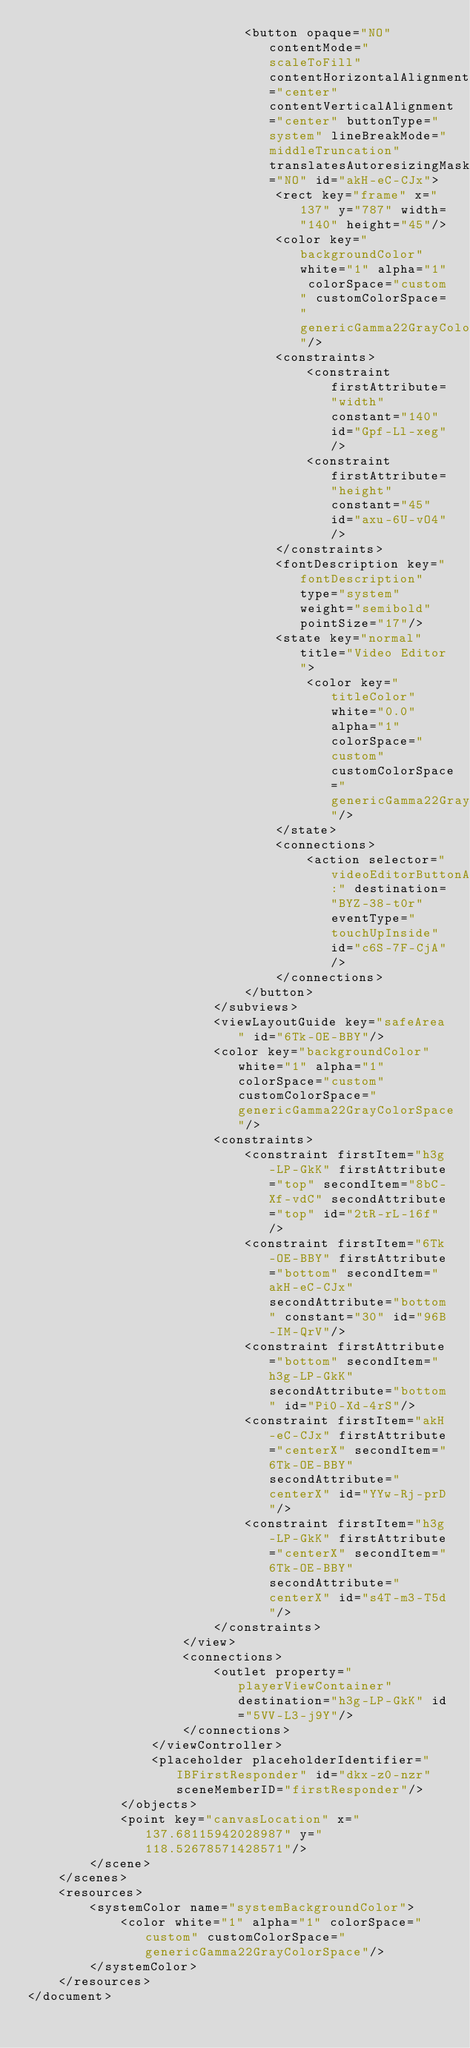<code> <loc_0><loc_0><loc_500><loc_500><_XML_>                            <button opaque="NO" contentMode="scaleToFill" contentHorizontalAlignment="center" contentVerticalAlignment="center" buttonType="system" lineBreakMode="middleTruncation" translatesAutoresizingMaskIntoConstraints="NO" id="akH-eC-CJx">
                                <rect key="frame" x="137" y="787" width="140" height="45"/>
                                <color key="backgroundColor" white="1" alpha="1" colorSpace="custom" customColorSpace="genericGamma22GrayColorSpace"/>
                                <constraints>
                                    <constraint firstAttribute="width" constant="140" id="Gpf-Ll-xeg"/>
                                    <constraint firstAttribute="height" constant="45" id="axu-6U-vO4"/>
                                </constraints>
                                <fontDescription key="fontDescription" type="system" weight="semibold" pointSize="17"/>
                                <state key="normal" title="Video Editor">
                                    <color key="titleColor" white="0.0" alpha="1" colorSpace="custom" customColorSpace="genericGamma22GrayColorSpace"/>
                                </state>
                                <connections>
                                    <action selector="videoEditorButtonAction:" destination="BYZ-38-t0r" eventType="touchUpInside" id="c6S-7F-CjA"/>
                                </connections>
                            </button>
                        </subviews>
                        <viewLayoutGuide key="safeArea" id="6Tk-OE-BBY"/>
                        <color key="backgroundColor" white="1" alpha="1" colorSpace="custom" customColorSpace="genericGamma22GrayColorSpace"/>
                        <constraints>
                            <constraint firstItem="h3g-LP-GkK" firstAttribute="top" secondItem="8bC-Xf-vdC" secondAttribute="top" id="2tR-rL-16f"/>
                            <constraint firstItem="6Tk-OE-BBY" firstAttribute="bottom" secondItem="akH-eC-CJx" secondAttribute="bottom" constant="30" id="96B-IM-QrV"/>
                            <constraint firstAttribute="bottom" secondItem="h3g-LP-GkK" secondAttribute="bottom" id="Pi0-Xd-4rS"/>
                            <constraint firstItem="akH-eC-CJx" firstAttribute="centerX" secondItem="6Tk-OE-BBY" secondAttribute="centerX" id="YYw-Rj-prD"/>
                            <constraint firstItem="h3g-LP-GkK" firstAttribute="centerX" secondItem="6Tk-OE-BBY" secondAttribute="centerX" id="s4T-m3-T5d"/>
                        </constraints>
                    </view>
                    <connections>
                        <outlet property="playerViewContainer" destination="h3g-LP-GkK" id="5VV-L3-j9Y"/>
                    </connections>
                </viewController>
                <placeholder placeholderIdentifier="IBFirstResponder" id="dkx-z0-nzr" sceneMemberID="firstResponder"/>
            </objects>
            <point key="canvasLocation" x="137.68115942028987" y="118.52678571428571"/>
        </scene>
    </scenes>
    <resources>
        <systemColor name="systemBackgroundColor">
            <color white="1" alpha="1" colorSpace="custom" customColorSpace="genericGamma22GrayColorSpace"/>
        </systemColor>
    </resources>
</document>
</code> 